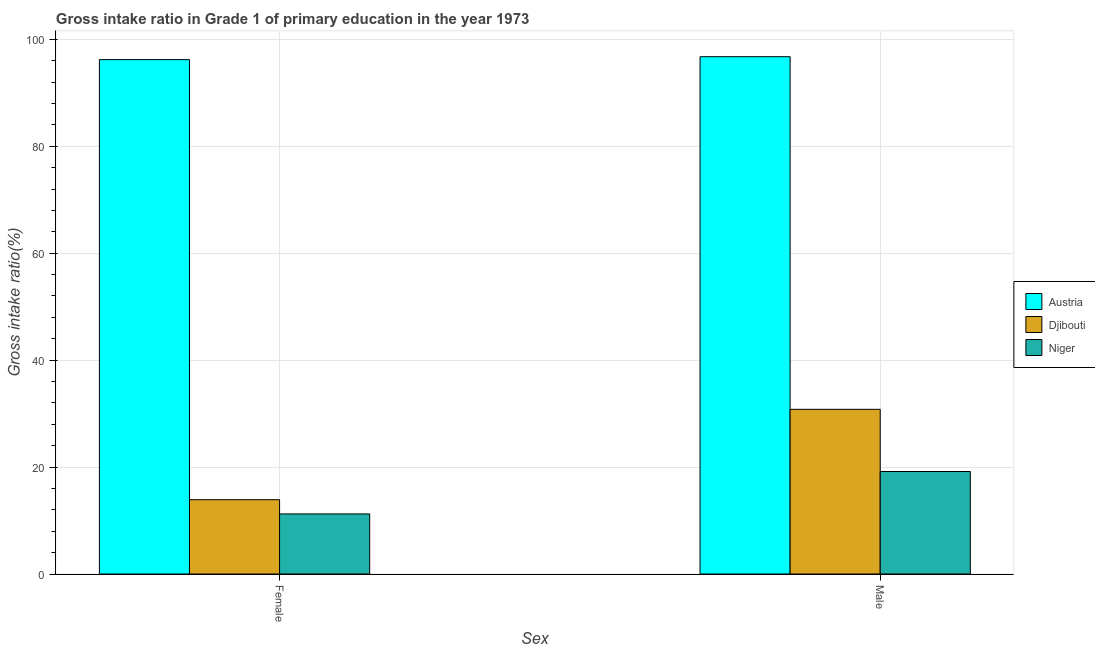How many groups of bars are there?
Your response must be concise. 2. Are the number of bars per tick equal to the number of legend labels?
Give a very brief answer. Yes. How many bars are there on the 2nd tick from the right?
Keep it short and to the point. 3. What is the gross intake ratio(female) in Niger?
Keep it short and to the point. 11.23. Across all countries, what is the maximum gross intake ratio(male)?
Your answer should be very brief. 96.75. Across all countries, what is the minimum gross intake ratio(male)?
Give a very brief answer. 19.17. In which country was the gross intake ratio(female) maximum?
Ensure brevity in your answer.  Austria. In which country was the gross intake ratio(female) minimum?
Provide a short and direct response. Niger. What is the total gross intake ratio(female) in the graph?
Offer a terse response. 121.33. What is the difference between the gross intake ratio(male) in Austria and that in Niger?
Offer a very short reply. 77.58. What is the difference between the gross intake ratio(male) in Austria and the gross intake ratio(female) in Djibouti?
Provide a succinct answer. 82.85. What is the average gross intake ratio(male) per country?
Make the answer very short. 48.9. What is the difference between the gross intake ratio(female) and gross intake ratio(male) in Austria?
Ensure brevity in your answer.  -0.55. What is the ratio of the gross intake ratio(male) in Niger to that in Djibouti?
Give a very brief answer. 0.62. In how many countries, is the gross intake ratio(male) greater than the average gross intake ratio(male) taken over all countries?
Offer a very short reply. 1. What does the 3rd bar from the left in Female represents?
Give a very brief answer. Niger. What does the 3rd bar from the right in Female represents?
Your response must be concise. Austria. How many bars are there?
Give a very brief answer. 6. How many countries are there in the graph?
Keep it short and to the point. 3. Does the graph contain any zero values?
Provide a short and direct response. No. Does the graph contain grids?
Your answer should be very brief. Yes. Where does the legend appear in the graph?
Give a very brief answer. Center right. How many legend labels are there?
Give a very brief answer. 3. What is the title of the graph?
Your answer should be very brief. Gross intake ratio in Grade 1 of primary education in the year 1973. What is the label or title of the X-axis?
Offer a terse response. Sex. What is the label or title of the Y-axis?
Provide a succinct answer. Gross intake ratio(%). What is the Gross intake ratio(%) in Austria in Female?
Offer a very short reply. 96.2. What is the Gross intake ratio(%) of Djibouti in Female?
Ensure brevity in your answer.  13.9. What is the Gross intake ratio(%) of Niger in Female?
Provide a short and direct response. 11.23. What is the Gross intake ratio(%) of Austria in Male?
Keep it short and to the point. 96.75. What is the Gross intake ratio(%) of Djibouti in Male?
Provide a short and direct response. 30.8. What is the Gross intake ratio(%) in Niger in Male?
Provide a short and direct response. 19.17. Across all Sex, what is the maximum Gross intake ratio(%) in Austria?
Ensure brevity in your answer.  96.75. Across all Sex, what is the maximum Gross intake ratio(%) in Djibouti?
Offer a very short reply. 30.8. Across all Sex, what is the maximum Gross intake ratio(%) of Niger?
Make the answer very short. 19.17. Across all Sex, what is the minimum Gross intake ratio(%) of Austria?
Make the answer very short. 96.2. Across all Sex, what is the minimum Gross intake ratio(%) in Djibouti?
Give a very brief answer. 13.9. Across all Sex, what is the minimum Gross intake ratio(%) of Niger?
Offer a terse response. 11.23. What is the total Gross intake ratio(%) of Austria in the graph?
Your response must be concise. 192.95. What is the total Gross intake ratio(%) of Djibouti in the graph?
Offer a very short reply. 44.7. What is the total Gross intake ratio(%) in Niger in the graph?
Your answer should be compact. 30.4. What is the difference between the Gross intake ratio(%) of Austria in Female and that in Male?
Your answer should be compact. -0.55. What is the difference between the Gross intake ratio(%) in Djibouti in Female and that in Male?
Give a very brief answer. -16.9. What is the difference between the Gross intake ratio(%) in Niger in Female and that in Male?
Your answer should be very brief. -7.93. What is the difference between the Gross intake ratio(%) in Austria in Female and the Gross intake ratio(%) in Djibouti in Male?
Ensure brevity in your answer.  65.4. What is the difference between the Gross intake ratio(%) of Austria in Female and the Gross intake ratio(%) of Niger in Male?
Your answer should be compact. 77.03. What is the difference between the Gross intake ratio(%) of Djibouti in Female and the Gross intake ratio(%) of Niger in Male?
Provide a short and direct response. -5.27. What is the average Gross intake ratio(%) of Austria per Sex?
Your response must be concise. 96.47. What is the average Gross intake ratio(%) of Djibouti per Sex?
Your answer should be very brief. 22.35. What is the average Gross intake ratio(%) of Niger per Sex?
Your answer should be compact. 15.2. What is the difference between the Gross intake ratio(%) in Austria and Gross intake ratio(%) in Djibouti in Female?
Your answer should be compact. 82.3. What is the difference between the Gross intake ratio(%) of Austria and Gross intake ratio(%) of Niger in Female?
Make the answer very short. 84.97. What is the difference between the Gross intake ratio(%) in Djibouti and Gross intake ratio(%) in Niger in Female?
Offer a terse response. 2.66. What is the difference between the Gross intake ratio(%) of Austria and Gross intake ratio(%) of Djibouti in Male?
Offer a terse response. 65.95. What is the difference between the Gross intake ratio(%) in Austria and Gross intake ratio(%) in Niger in Male?
Offer a terse response. 77.58. What is the difference between the Gross intake ratio(%) of Djibouti and Gross intake ratio(%) of Niger in Male?
Offer a very short reply. 11.63. What is the ratio of the Gross intake ratio(%) in Djibouti in Female to that in Male?
Provide a short and direct response. 0.45. What is the ratio of the Gross intake ratio(%) in Niger in Female to that in Male?
Provide a succinct answer. 0.59. What is the difference between the highest and the second highest Gross intake ratio(%) of Austria?
Provide a succinct answer. 0.55. What is the difference between the highest and the second highest Gross intake ratio(%) in Djibouti?
Offer a very short reply. 16.9. What is the difference between the highest and the second highest Gross intake ratio(%) in Niger?
Make the answer very short. 7.93. What is the difference between the highest and the lowest Gross intake ratio(%) of Austria?
Give a very brief answer. 0.55. What is the difference between the highest and the lowest Gross intake ratio(%) of Djibouti?
Your response must be concise. 16.9. What is the difference between the highest and the lowest Gross intake ratio(%) in Niger?
Give a very brief answer. 7.93. 